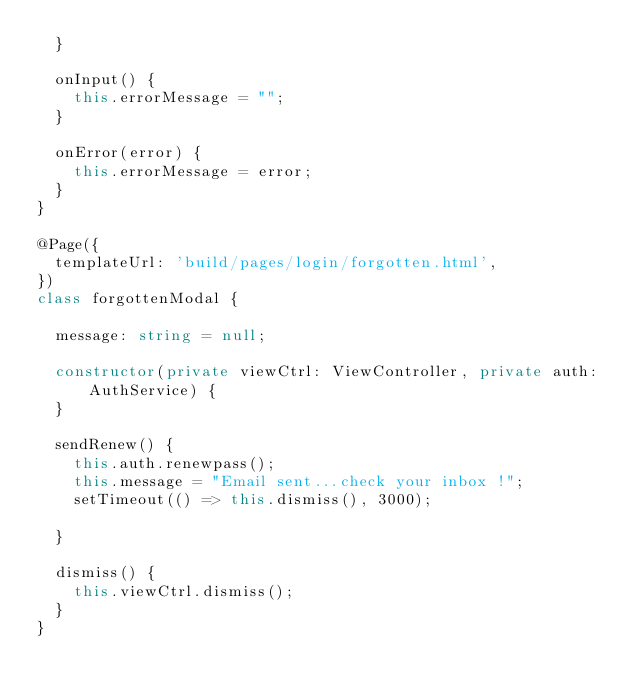Convert code to text. <code><loc_0><loc_0><loc_500><loc_500><_TypeScript_>  }

  onInput() {
  	this.errorMessage = "";
  }

  onError(error) {
    this.errorMessage = error;
  }
}

@Page({
	templateUrl: 'build/pages/login/forgotten.html',
})
class forgottenModal {

	message: string = null;

	constructor(private viewCtrl: ViewController, private auth: AuthService) {
	}

	sendRenew() {
		this.auth.renewpass();
		this.message = "Email sent...check your inbox !";
		setTimeout(() => this.dismiss(), 3000);

	}

	dismiss() {
		this.viewCtrl.dismiss();
	}
}
</code> 